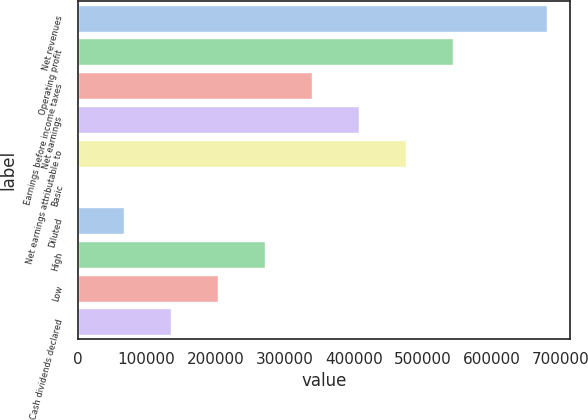Convert chart. <chart><loc_0><loc_0><loc_500><loc_500><bar_chart><fcel>Net revenues<fcel>Operating profit<fcel>Earnings before income taxes<fcel>Net earnings<fcel>Net earnings attributable to<fcel>Basic<fcel>Diluted<fcel>High<fcel>Low<fcel>Cash dividends declared<nl><fcel>679453<fcel>543562<fcel>339727<fcel>407672<fcel>475617<fcel>0.24<fcel>67945.5<fcel>271781<fcel>203836<fcel>135891<nl></chart> 